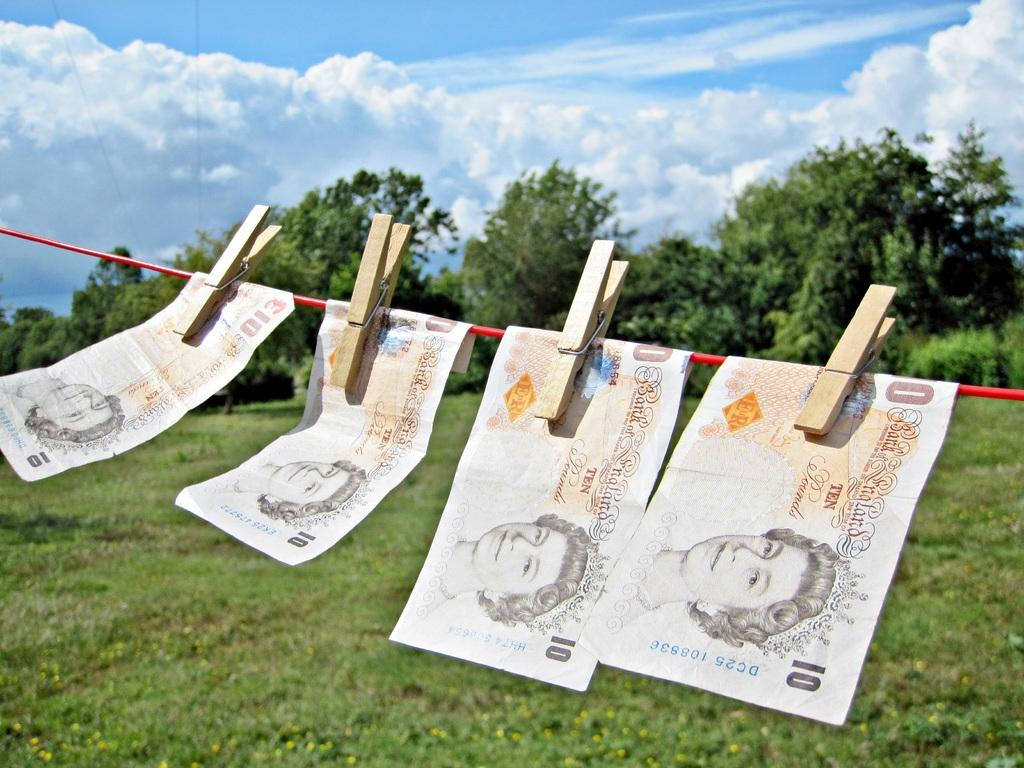<image>
Write a terse but informative summary of the picture. 4 Canadian 10 dollar bills are hung on the clothesline with pins. 